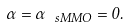Convert formula to latex. <formula><loc_0><loc_0><loc_500><loc_500>\alpha = \alpha _ { \ s M M O } = 0 .</formula> 